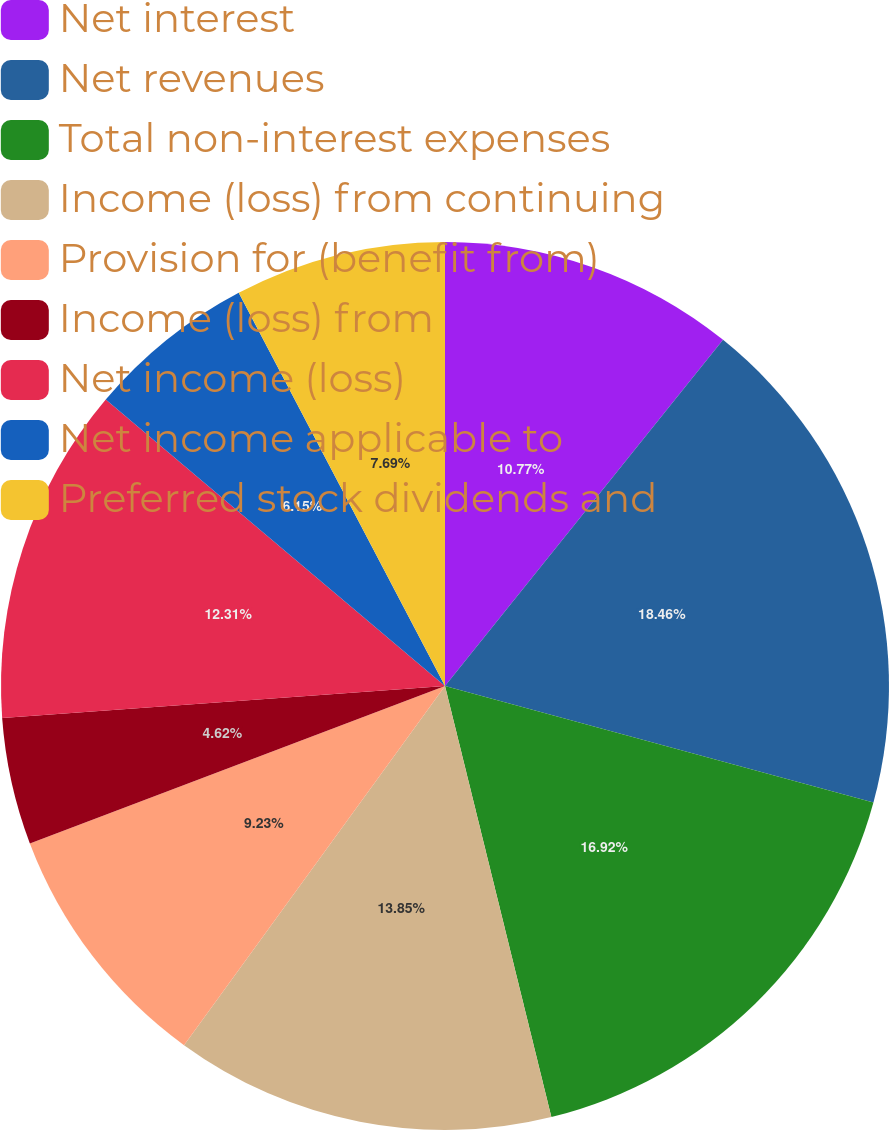<chart> <loc_0><loc_0><loc_500><loc_500><pie_chart><fcel>Net interest<fcel>Net revenues<fcel>Total non-interest expenses<fcel>Income (loss) from continuing<fcel>Provision for (benefit from)<fcel>Income (loss) from<fcel>Net income (loss)<fcel>Net income applicable to<fcel>Preferred stock dividends and<nl><fcel>10.77%<fcel>18.46%<fcel>16.92%<fcel>13.85%<fcel>9.23%<fcel>4.62%<fcel>12.31%<fcel>6.15%<fcel>7.69%<nl></chart> 